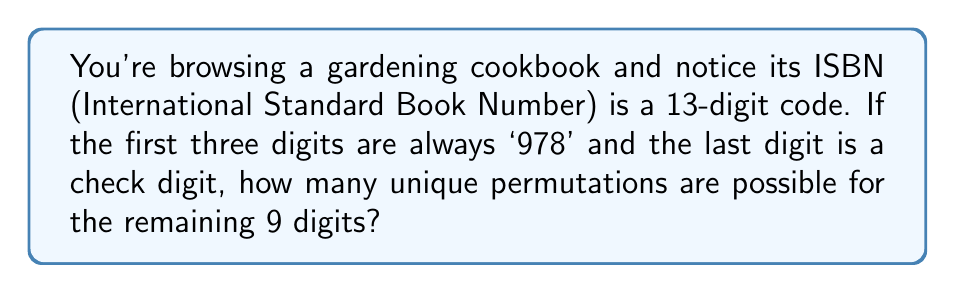Can you solve this math problem? Let's approach this step-by-step:

1) An ISBN-13 has 13 digits in total.

2) The first three digits are fixed as '978' for books.

3) The last digit is a check digit, which is calculated based on the other 12 digits.

4) This leaves 9 digits that can vary.

5) Each of these 9 digits can be any number from 0 to 9.

6) In permutation problems, we use the multiplication principle. For each digit, we have 10 choices (0-9).

7) Therefore, the total number of permutations is:

   $$10 \times 10 \times 10 \times 10 \times 10 \times 10 \times 10 \times 10 \times 10 = 10^9$$

8) We can write this as:

   $$\text{Number of permutations} = 10^9 = 1,000,000,000$$

Thus, there are one billion possible permutations for these 9 digits in the ISBN.
Answer: $10^9$ or 1,000,000,000 